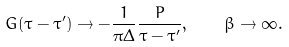<formula> <loc_0><loc_0><loc_500><loc_500>G ( \tau - \tau ^ { \prime } ) \to - \frac { 1 } { \pi \Delta } \frac { P } { \tau - \tau ^ { \prime } } , \quad \beta \to \infty .</formula> 